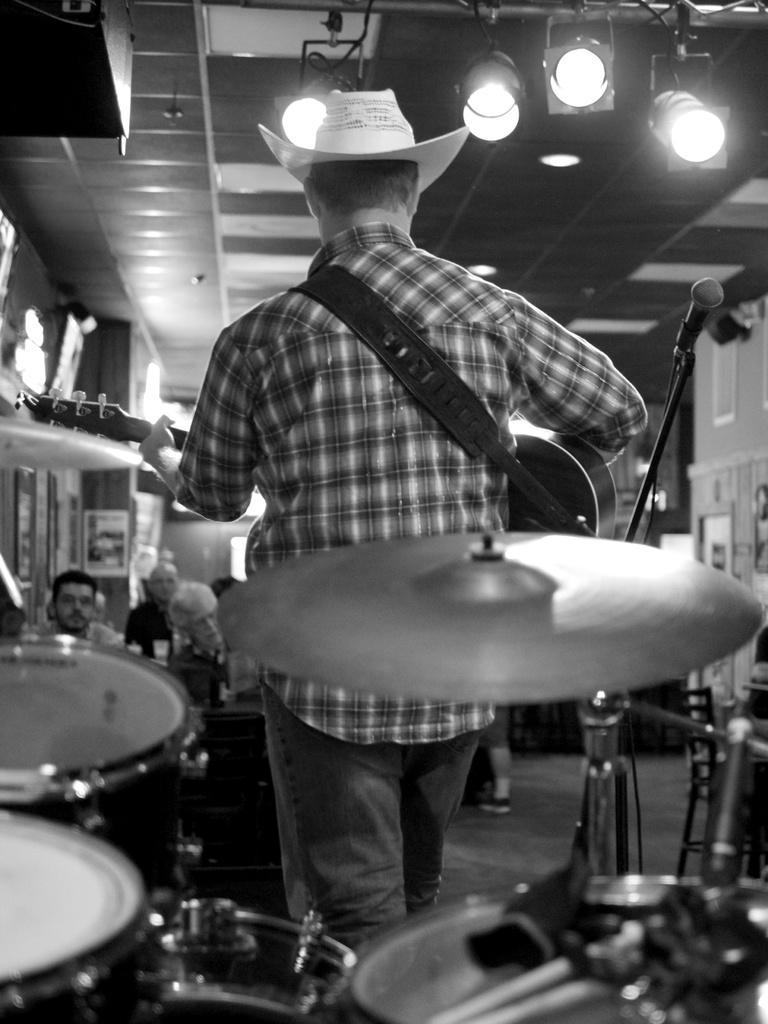How would you summarize this image in a sentence or two? In the foreground I can see a person is playing a guitar. In the background I can see a crowd and a wall. On the top I can see a rooftop on which lights are mounted. This image is taken in a hall. 